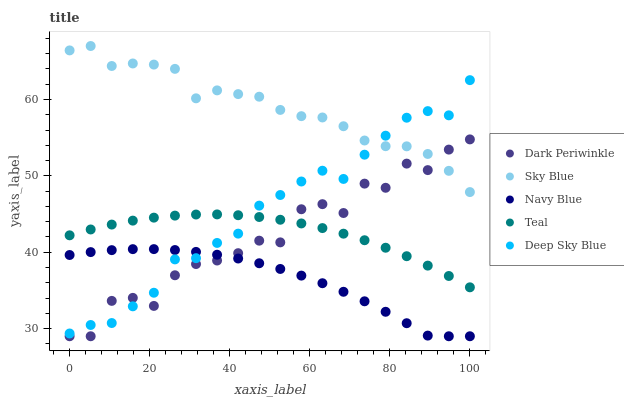Does Navy Blue have the minimum area under the curve?
Answer yes or no. Yes. Does Sky Blue have the maximum area under the curve?
Answer yes or no. Yes. Does Deep Sky Blue have the minimum area under the curve?
Answer yes or no. No. Does Deep Sky Blue have the maximum area under the curve?
Answer yes or no. No. Is Teal the smoothest?
Answer yes or no. Yes. Is Dark Periwinkle the roughest?
Answer yes or no. Yes. Is Deep Sky Blue the smoothest?
Answer yes or no. No. Is Deep Sky Blue the roughest?
Answer yes or no. No. Does Dark Periwinkle have the lowest value?
Answer yes or no. Yes. Does Deep Sky Blue have the lowest value?
Answer yes or no. No. Does Sky Blue have the highest value?
Answer yes or no. Yes. Does Deep Sky Blue have the highest value?
Answer yes or no. No. Is Navy Blue less than Sky Blue?
Answer yes or no. Yes. Is Teal greater than Navy Blue?
Answer yes or no. Yes. Does Dark Periwinkle intersect Deep Sky Blue?
Answer yes or no. Yes. Is Dark Periwinkle less than Deep Sky Blue?
Answer yes or no. No. Is Dark Periwinkle greater than Deep Sky Blue?
Answer yes or no. No. Does Navy Blue intersect Sky Blue?
Answer yes or no. No. 